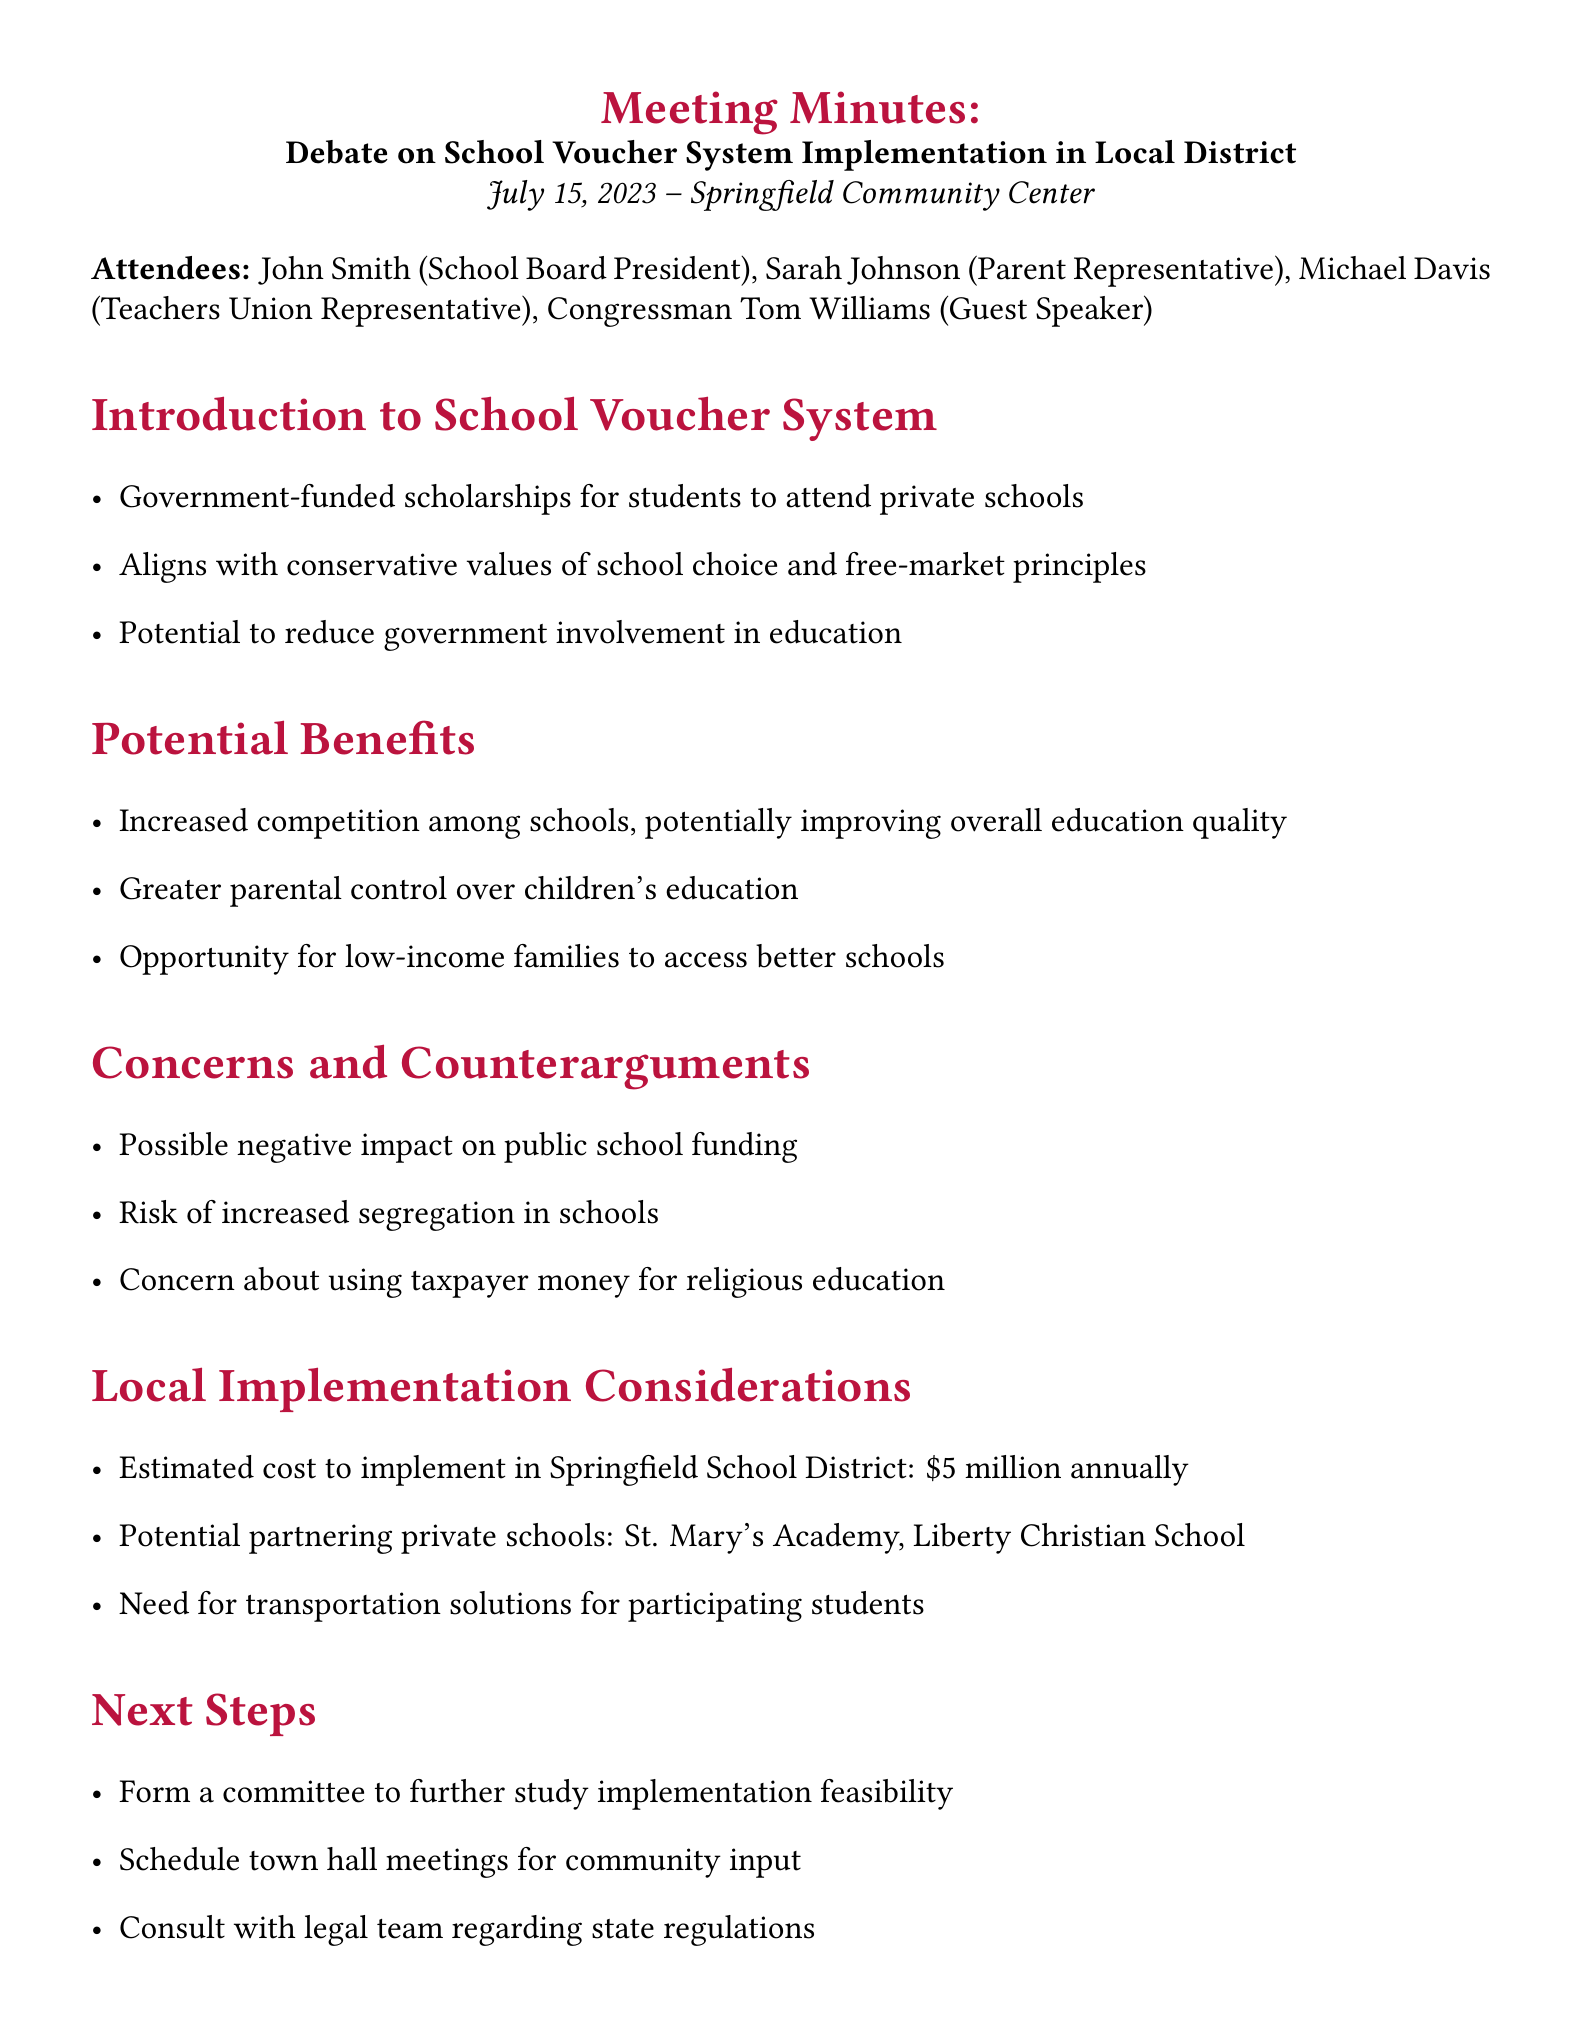What is the meeting title? The meeting title is specified at the beginning of the document.
Answer: Debate on School Voucher System Implementation in Local District Who is the guest speaker? The document lists attendees, including the guest speaker, under a separate section.
Answer: Congressman Tom Williams What is the estimated cost to implement the voucher system? The estimated cost is mentioned under the local implementation considerations.
Answer: $5 million annually What are the potential partnering private schools? Potential partnering schools are listed in the local implementation considerations.
Answer: St. Mary's Academy, Liberty Christian School What is the primary concern about public schooling mentioned? The concerns and counterarguments section highlights potential issues with the public schools.
Answer: Possible negative impact on public school funding What is one of the action items assigned to John Smith? The action items section specifies tasks assigned to different attendees.
Answer: Reach out to neighboring districts with voucher programs for insights What is one benefit of the school voucher system discussed? The potential benefits section includes several advantages of the system.
Answer: Increased competition among schools What is one step proposed for community involvement? The next steps section suggests how to gather community feedback.
Answer: Schedule town hall meetings for community input What principle does the voucher system align with according to the document? The introduction mentions values associated with the school voucher system.
Answer: School choice and free-market principles 